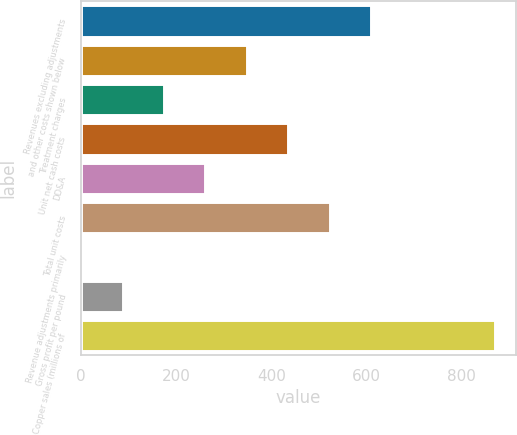Convert chart. <chart><loc_0><loc_0><loc_500><loc_500><bar_chart><fcel>Revenues excluding adjustments<fcel>and other costs shown below<fcel>Treatment charges<fcel>Unit net cash costs<fcel>DD&A<fcel>Total unit costs<fcel>Revenue adjustments primarily<fcel>Gross profit per pound<fcel>Copper sales (millions of<nl><fcel>609.73<fcel>348.43<fcel>174.23<fcel>435.53<fcel>261.33<fcel>522.63<fcel>0.03<fcel>87.13<fcel>871<nl></chart> 